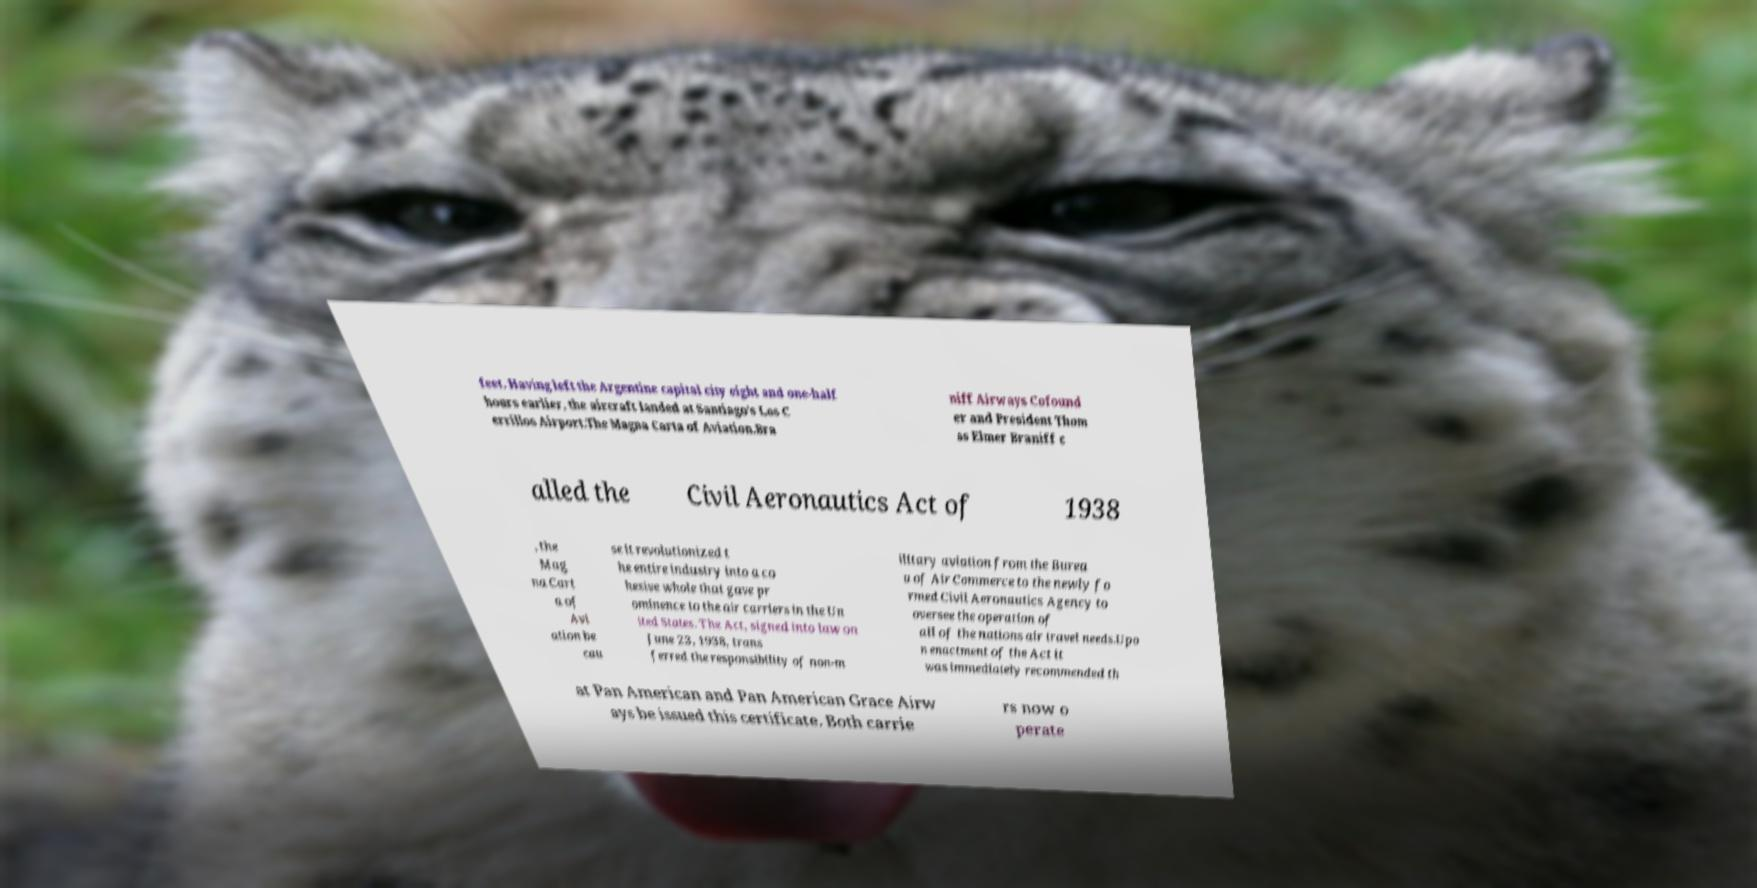Can you read and provide the text displayed in the image?This photo seems to have some interesting text. Can you extract and type it out for me? feet. Having left the Argentine capital city eight and one-half hours earlier, the aircraft landed at Santiago's Los C errillos Airport.The Magna Carta of Aviation.Bra niff Airways Cofound er and President Thom as Elmer Braniff c alled the Civil Aeronautics Act of 1938 , the Mag na Cart a of Avi ation be cau se it revolutionized t he entire industry into a co hesive whole that gave pr ominence to the air carriers in the Un ited States. The Act, signed into law on June 23, 1938, trans ferred the responsibility of non-m ilitary aviation from the Burea u of Air Commerce to the newly fo rmed Civil Aeronautics Agency to oversee the operation of all of the nations air travel needs.Upo n enactment of the Act it was immediately recommended th at Pan American and Pan American Grace Airw ays be issued this certificate. Both carrie rs now o perate 